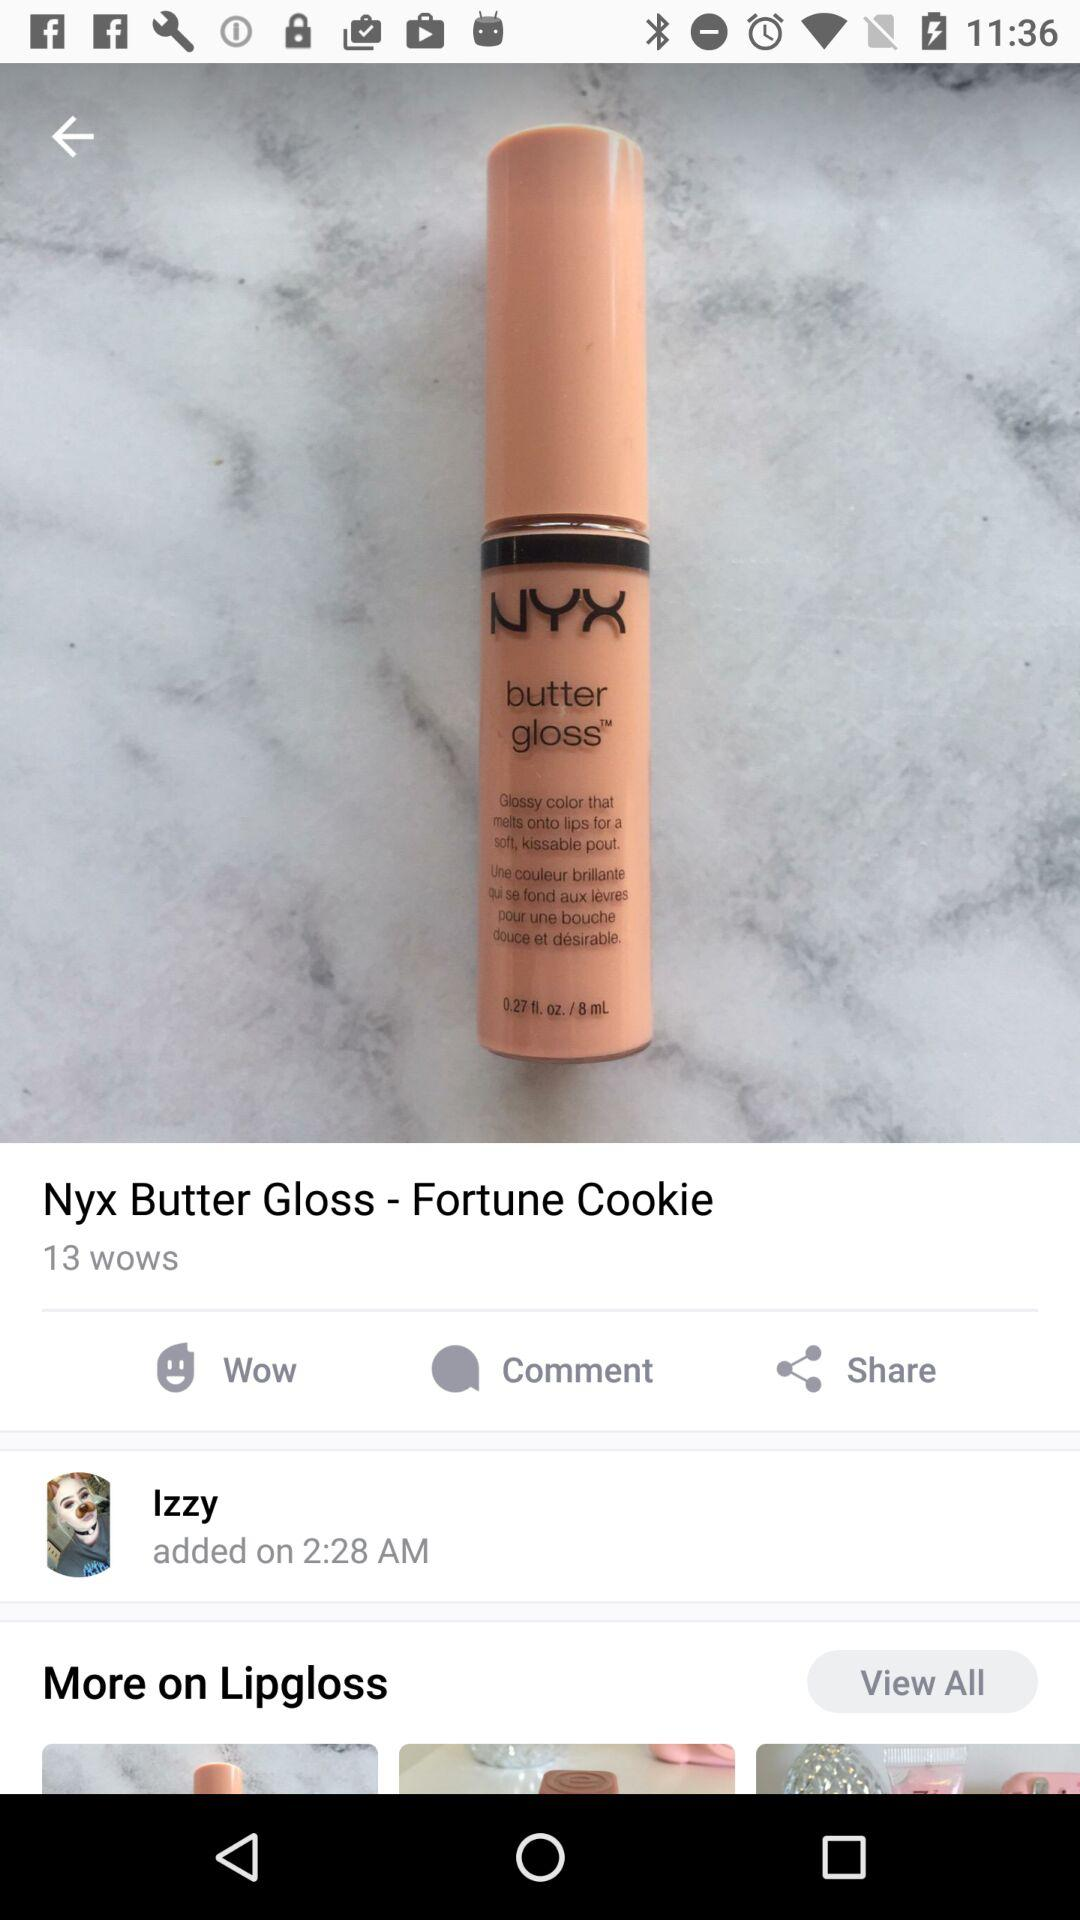How many more wows does this product have than comments?
Answer the question using a single word or phrase. 13 